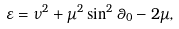Convert formula to latex. <formula><loc_0><loc_0><loc_500><loc_500>\varepsilon = \nu ^ { 2 } + \mu ^ { 2 } \sin ^ { 2 } \theta _ { 0 } - 2 \mu ,</formula> 